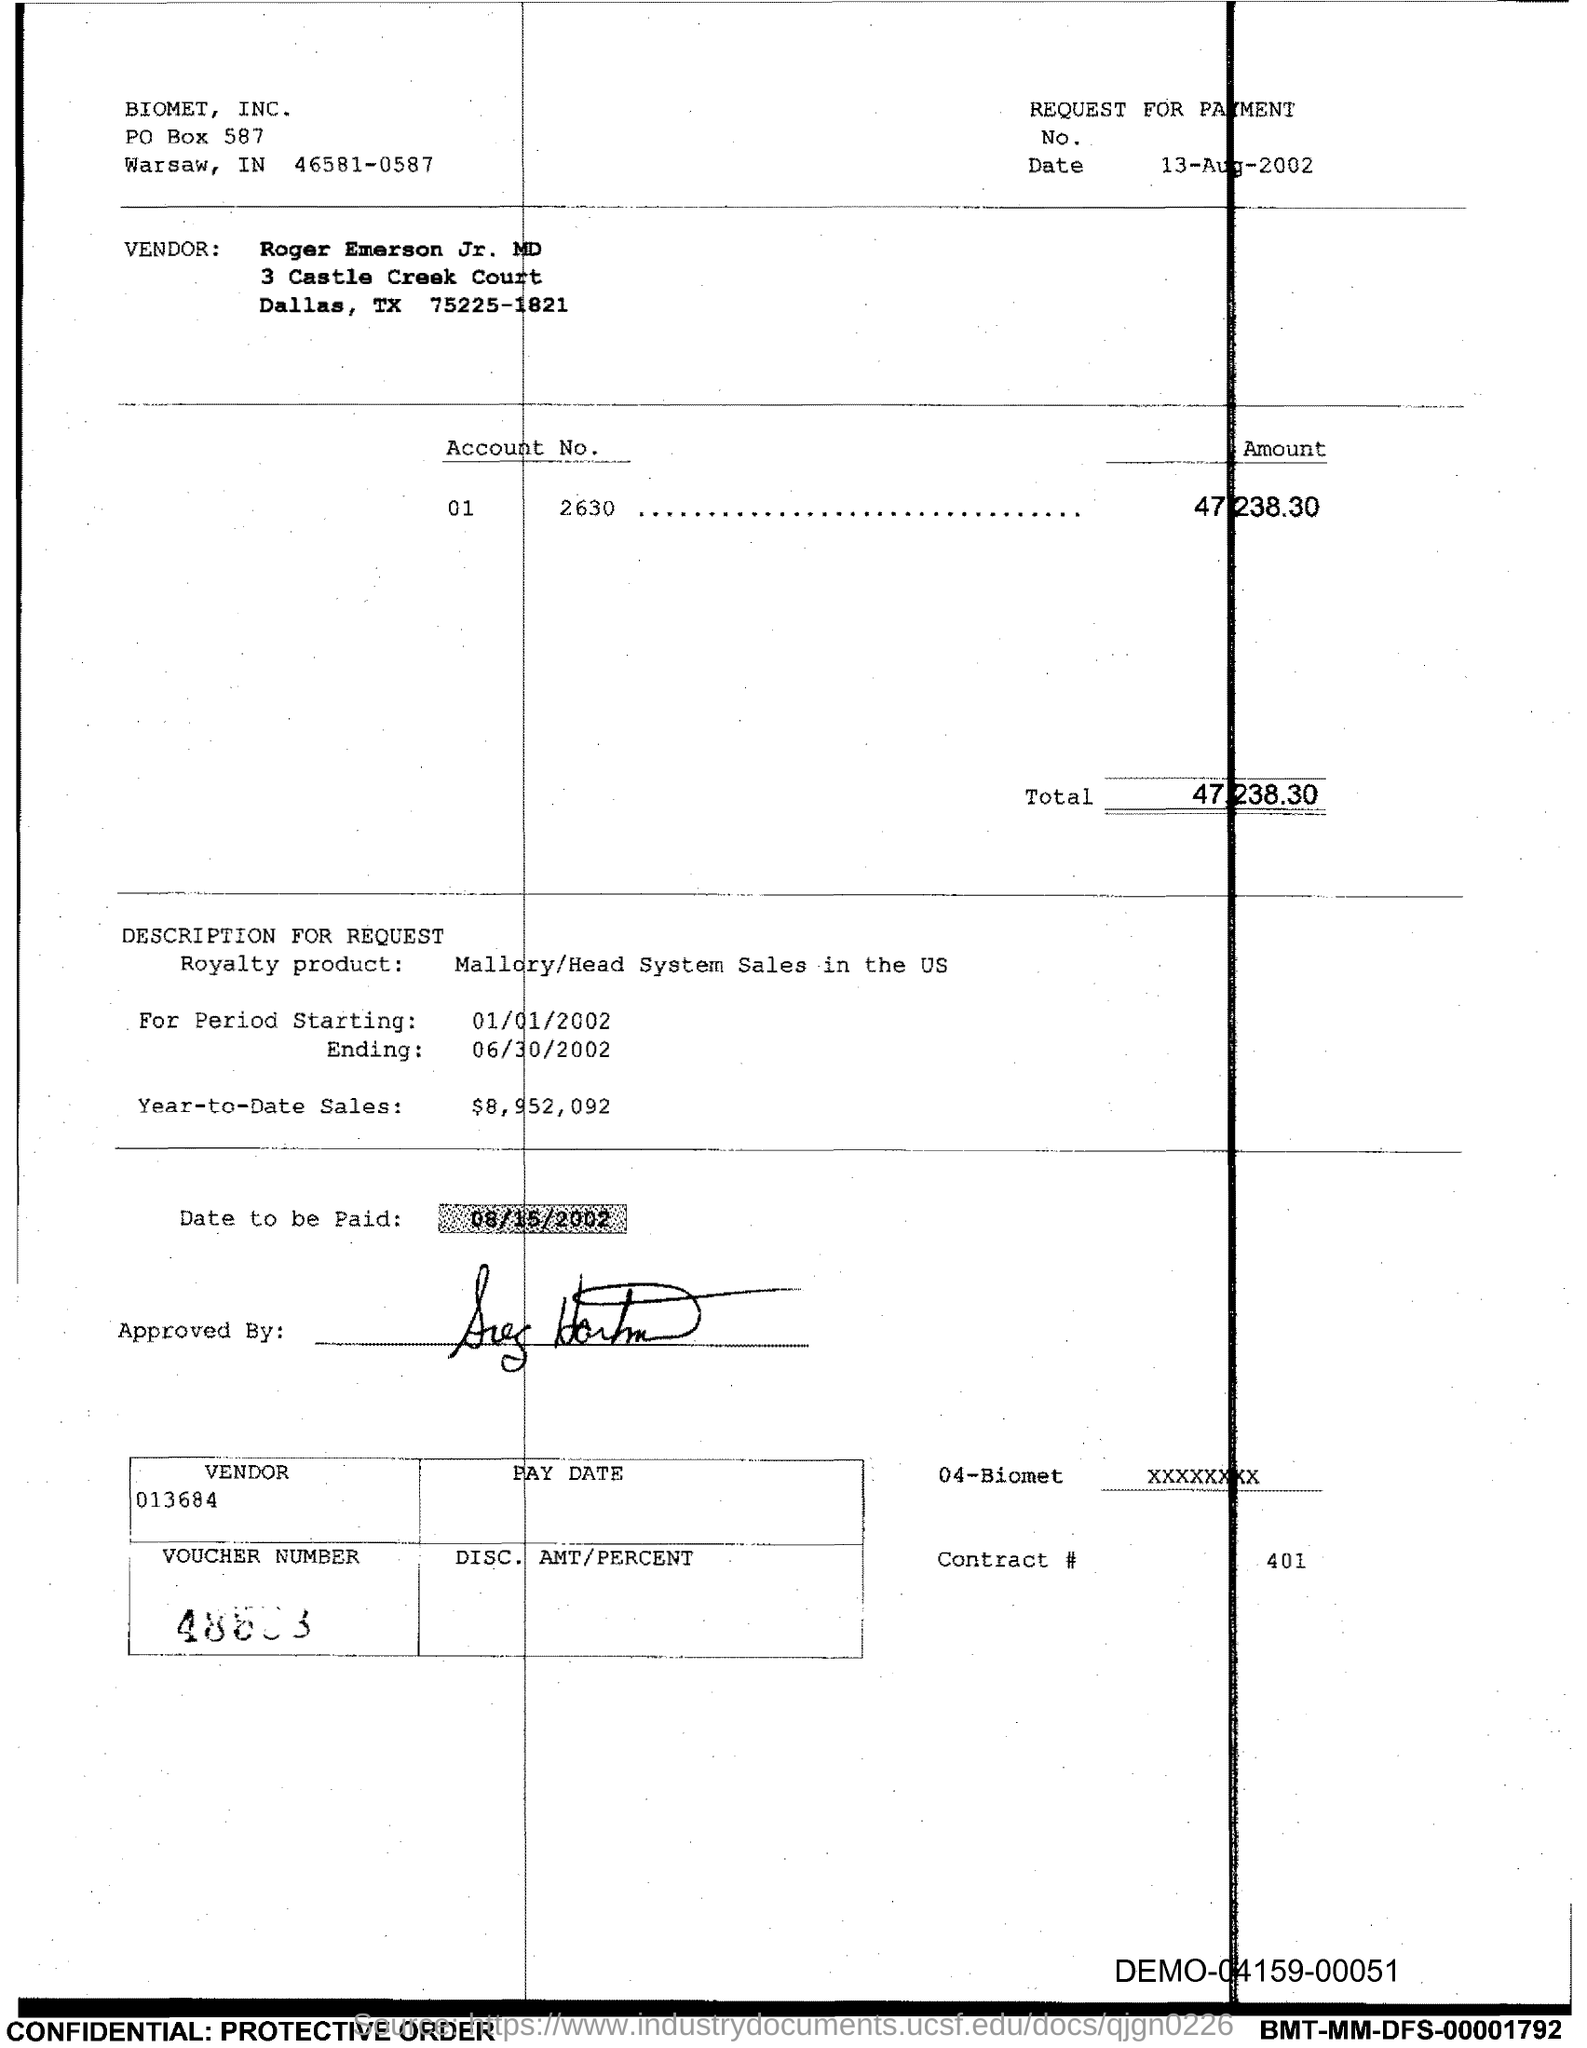What is the PO Box Number mentioned in the document?
Provide a short and direct response. 587. What is the Total?
Offer a very short reply. 47,238.30. 